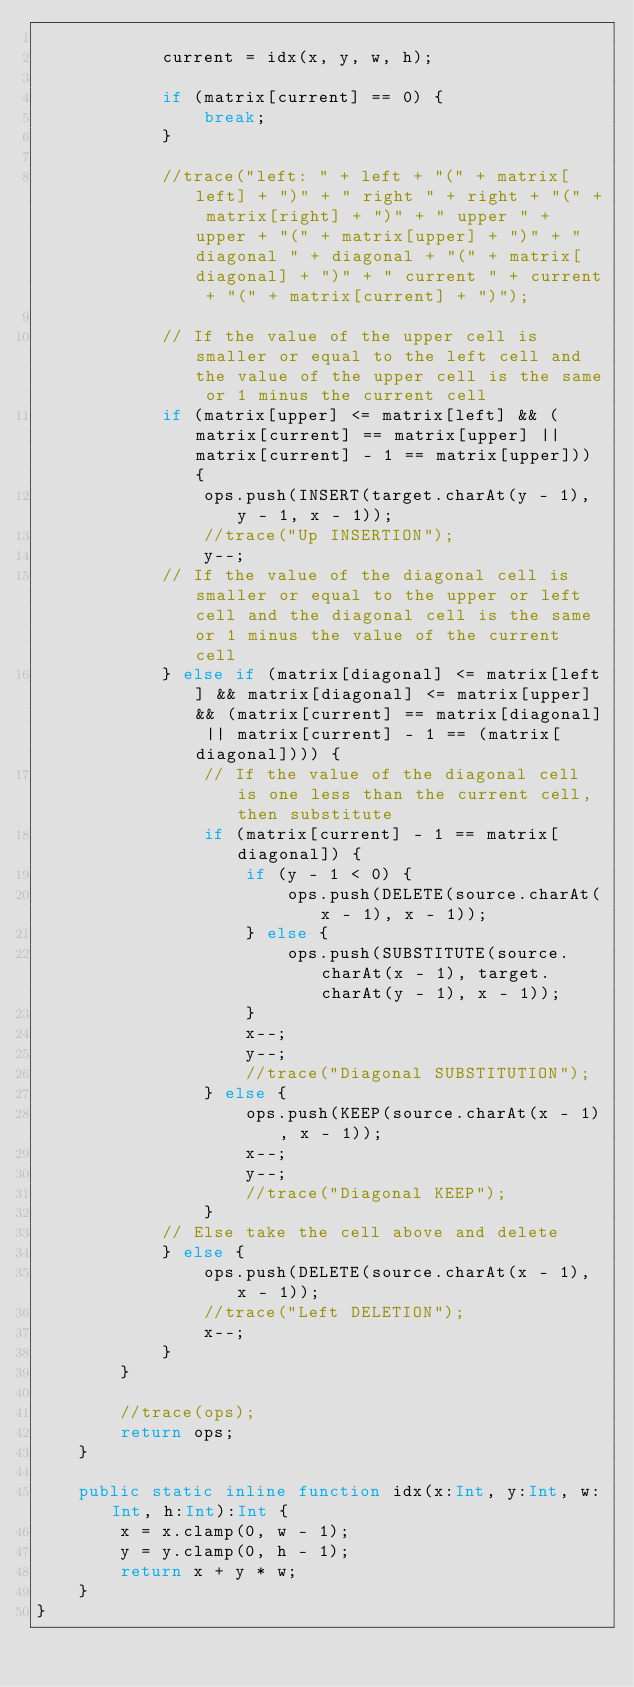<code> <loc_0><loc_0><loc_500><loc_500><_Haxe_>			
			current = idx(x, y, w, h);
			
			if (matrix[current] == 0) {
				break;
			}
			
			//trace("left: " + left + "(" + matrix[left] + ")" + " right " + right + "(" + matrix[right] + ")" + " upper " + upper + "(" + matrix[upper] + ")" + " diagonal " + diagonal + "(" + matrix[diagonal] + ")" + " current " + current + "(" + matrix[current] + ")");

			// If the value of the upper cell is smaller or equal to the left cell and the value of the upper cell is the same or 1 minus the current cell
			if (matrix[upper] <= matrix[left] && (matrix[current] == matrix[upper] || matrix[current] - 1 == matrix[upper])) {
				ops.push(INSERT(target.charAt(y - 1), y - 1, x - 1));
				//trace("Up INSERTION");
				y--;
			// If the value of the diagonal cell is smaller or equal to the upper or left cell and the diagonal cell is the same or 1 minus the value of the current cell
			} else if (matrix[diagonal] <= matrix[left] && matrix[diagonal] <= matrix[upper] && (matrix[current] == matrix[diagonal] || matrix[current] - 1 == (matrix[diagonal]))) {
				// If the value of the diagonal cell is one less than the current cell, then substitute
				if (matrix[current] - 1 == matrix[diagonal]) {
					if (y - 1 < 0) {
						ops.push(DELETE(source.charAt(x - 1), x - 1));
					} else {
						ops.push(SUBSTITUTE(source.charAt(x - 1), target.charAt(y - 1), x - 1));
					}
					x--;
					y--;
					//trace("Diagonal SUBSTITUTION");
				} else {
					ops.push(KEEP(source.charAt(x - 1), x - 1));
					x--;
					y--;
					//trace("Diagonal KEEP");
				}
			// Else take the cell above and delete
			} else {
				ops.push(DELETE(source.charAt(x - 1), x - 1));
				//trace("Left DELETION");
				x--;
			}
		}
		
		//trace(ops);
		return ops;
	}
	
	public static inline function idx(x:Int, y:Int, w:Int, h:Int):Int {
		x = x.clamp(0, w - 1);
		y = y.clamp(0, h - 1);
		return x + y * w;
	}
}</code> 